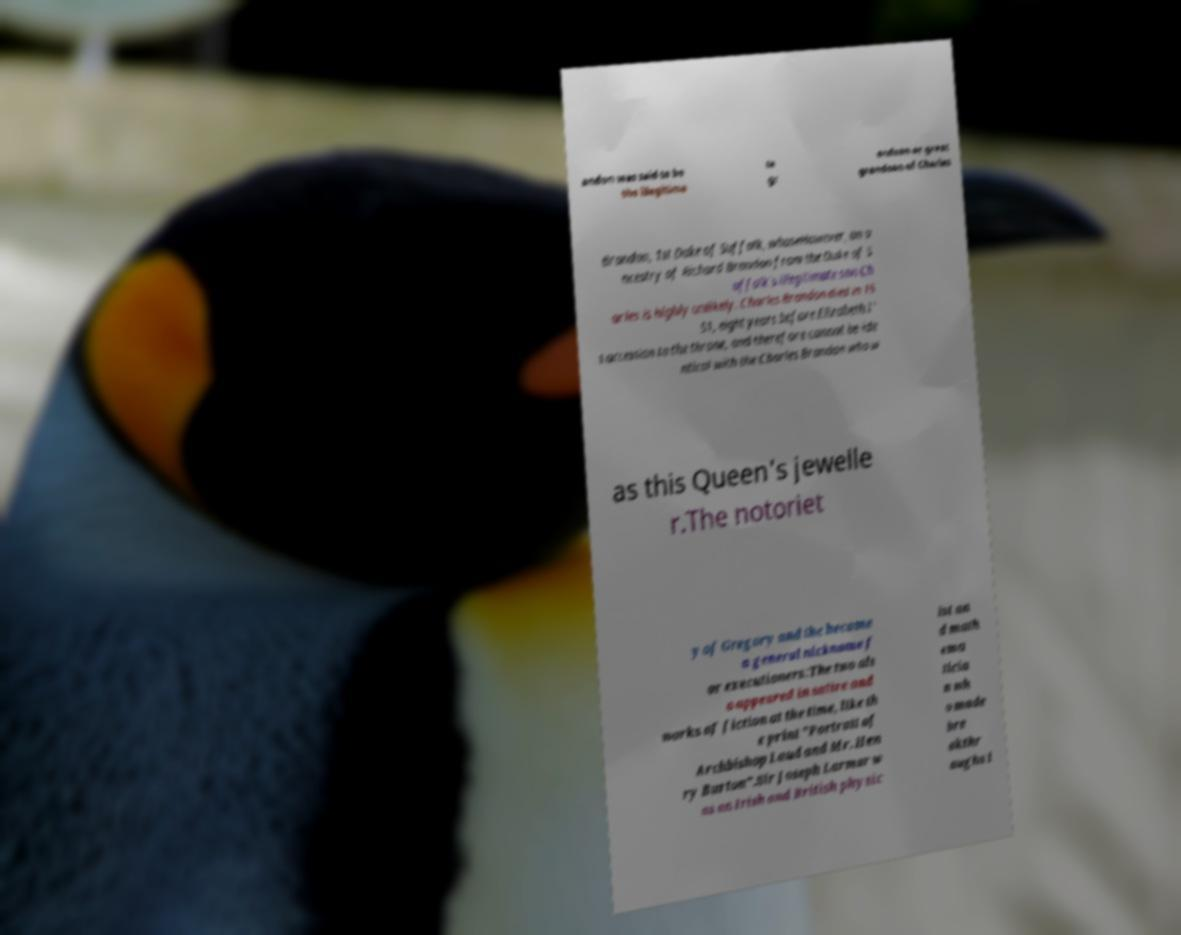Can you accurately transcribe the text from the provided image for me? andon was said to be the illegitima te gr andson or great grandson of Charles Brandon, 1st Duke of Suffolk, whoseHowever, an a ncestry of Richard Brandon from the Duke of S uffolk's illegitimate son Ch arles is highly unlikely. Charles Brandon died in 15 51, eight years before Elizabeth I' s accession to the throne, and therefore cannot be ide ntical with the Charles Brandon who w as this Queen's jewelle r.The notoriet y of Gregory and the became a general nickname f or executioners:The two als o appeared in satire and works of fiction at the time, like th e print "Portrait of Archbishop Laud and Mr. Hen ry Burton".Sir Joseph Larmor w as an Irish and British physic ist an d math ema ticia n wh o made bre akthr oughs i 